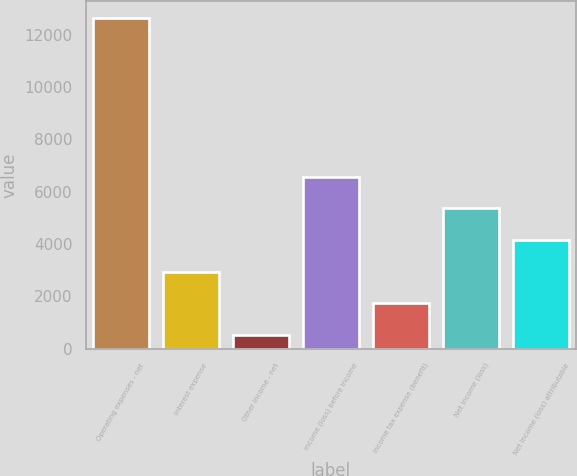Convert chart. <chart><loc_0><loc_0><loc_500><loc_500><bar_chart><fcel>Operating expenses - net<fcel>Interest expense<fcel>Other income - net<fcel>Income (loss) before income<fcel>Income tax expense (benefit)<fcel>Net income (loss)<fcel>Net income (loss) attributable<nl><fcel>12637<fcel>2945<fcel>522<fcel>6579.5<fcel>1733.5<fcel>5368<fcel>4156.5<nl></chart> 